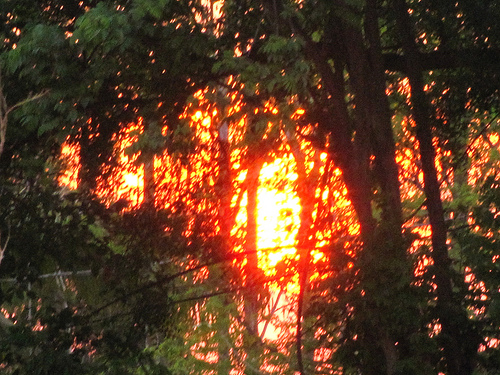<image>
Is the sun in front of the tree? No. The sun is not in front of the tree. The spatial positioning shows a different relationship between these objects. 